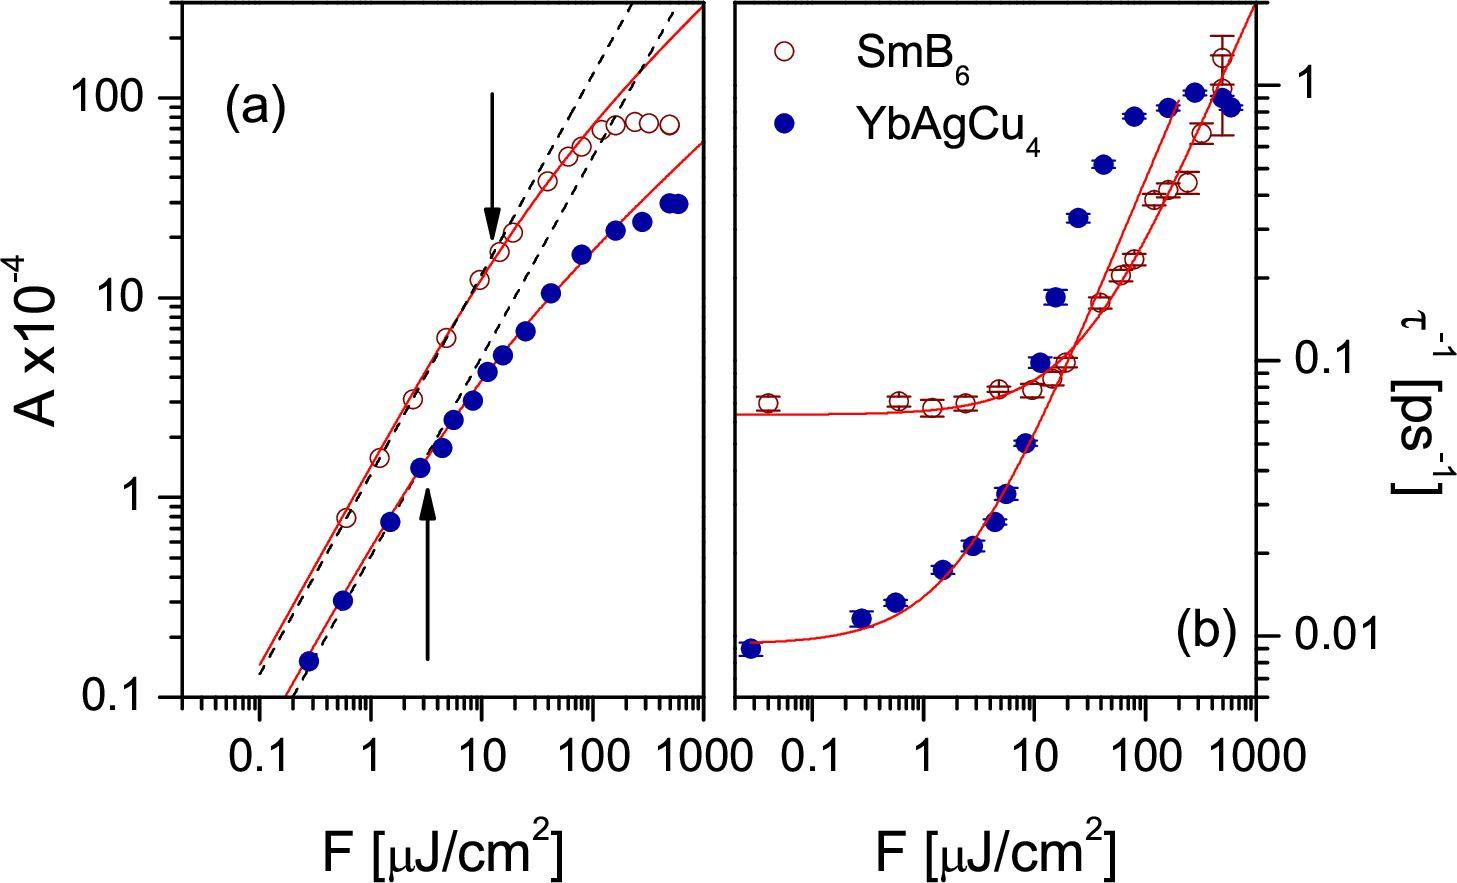Can you explain the comparison between figure (a) and figure (b) in this image? Sure! In figure (a), the relationship between 'A' and 'F' is depicted with a significant change in trend at a particular threshold, indicating a strong, possibly non-linear relationship. Figure (b), however, shows a different type of curve which doesn't exhibit such a change in slope but instead follows a more gradual decay. This may suggest different underlying physics or operational behaviors influencing 'A' and 'F' in two scenarios illustrated by SmB6 and YbAgCu4, respectively. 